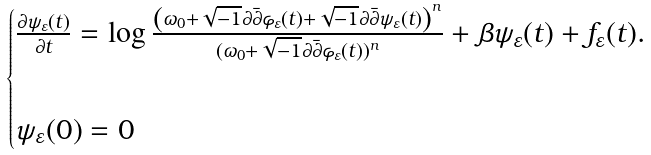<formula> <loc_0><loc_0><loc_500><loc_500>\begin{cases} \frac { \partial \psi _ { \varepsilon } ( t ) } { \partial t } = \log \frac { \left ( \omega _ { 0 } + \sqrt { - 1 } \partial \bar { \partial } \varphi _ { \varepsilon } ( t ) + \sqrt { - 1 } \partial \bar { \partial } \psi _ { \varepsilon } ( t ) \right ) ^ { n } } { ( \omega _ { 0 } + \sqrt { - 1 } \partial \bar { \partial } \varphi _ { \varepsilon } ( t ) ) ^ { n } } + \beta \psi _ { \varepsilon } ( t ) + f _ { \varepsilon } ( t ) . \\ \\ \psi _ { \varepsilon } ( 0 ) = 0 \\ \end{cases}</formula> 